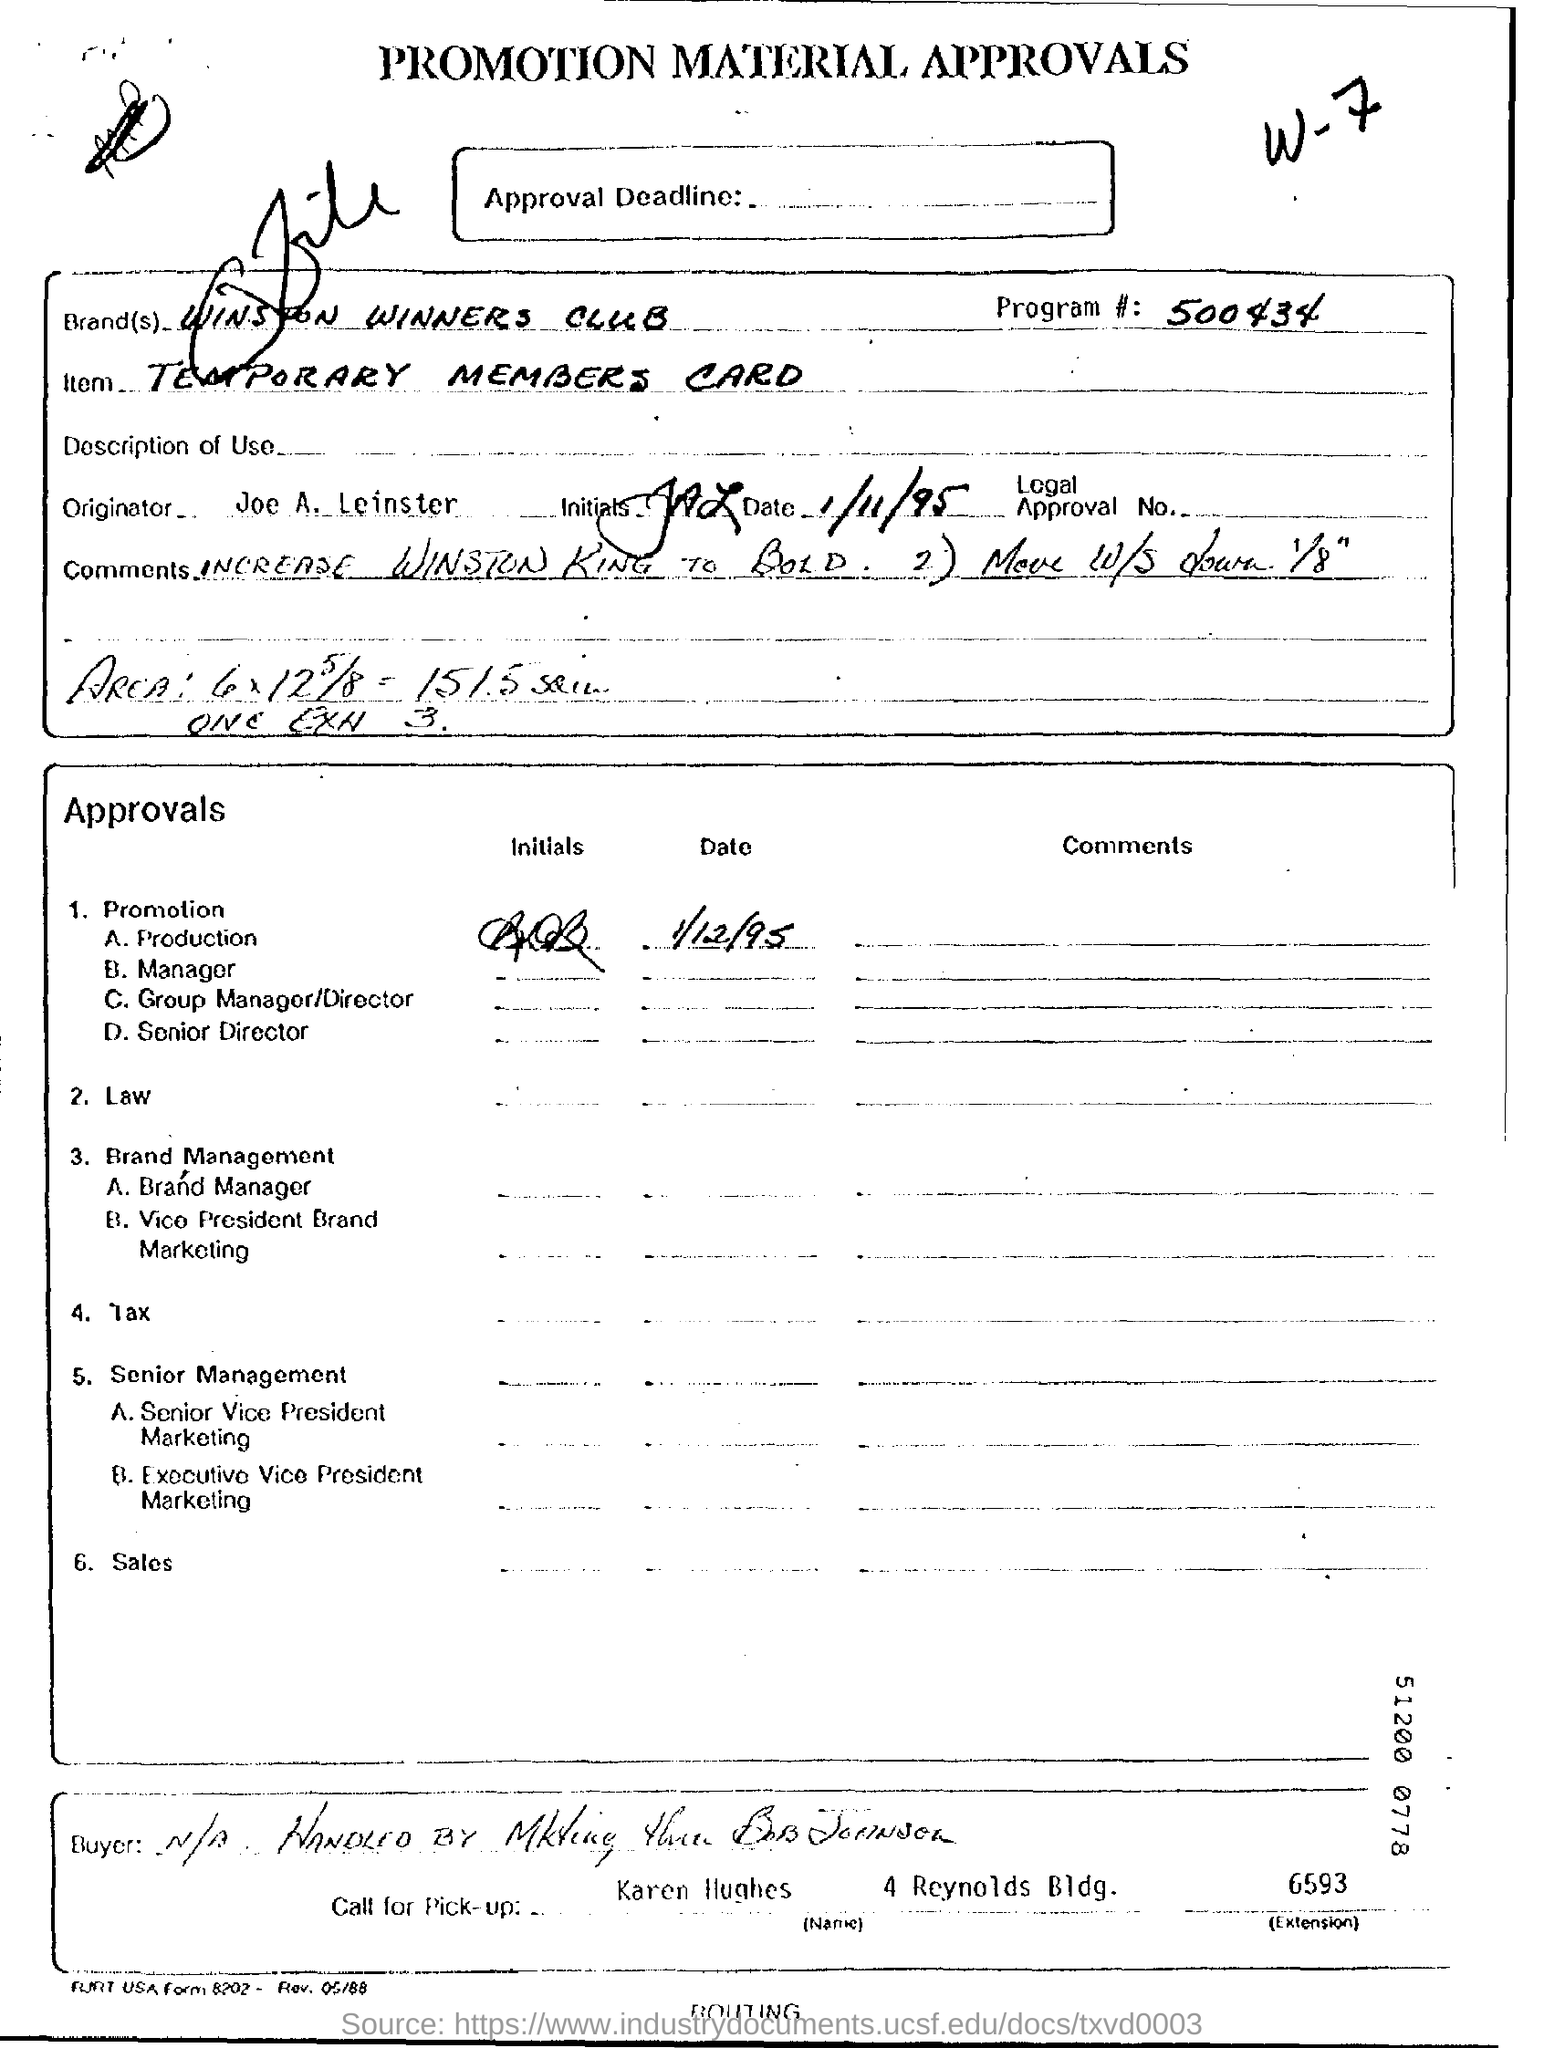What is the Title of the document ?
Ensure brevity in your answer.  Promotion Material Approvals. What is the Program Number ?
Your response must be concise. 500434. What is the Item ?
Provide a short and direct response. TEMPORARY MEMBERS CARD. Who is the Originator   ?
Offer a terse response. Joe A. Leinster. What is the extension number of Karen Hughes?
Keep it short and to the point. 6593. 